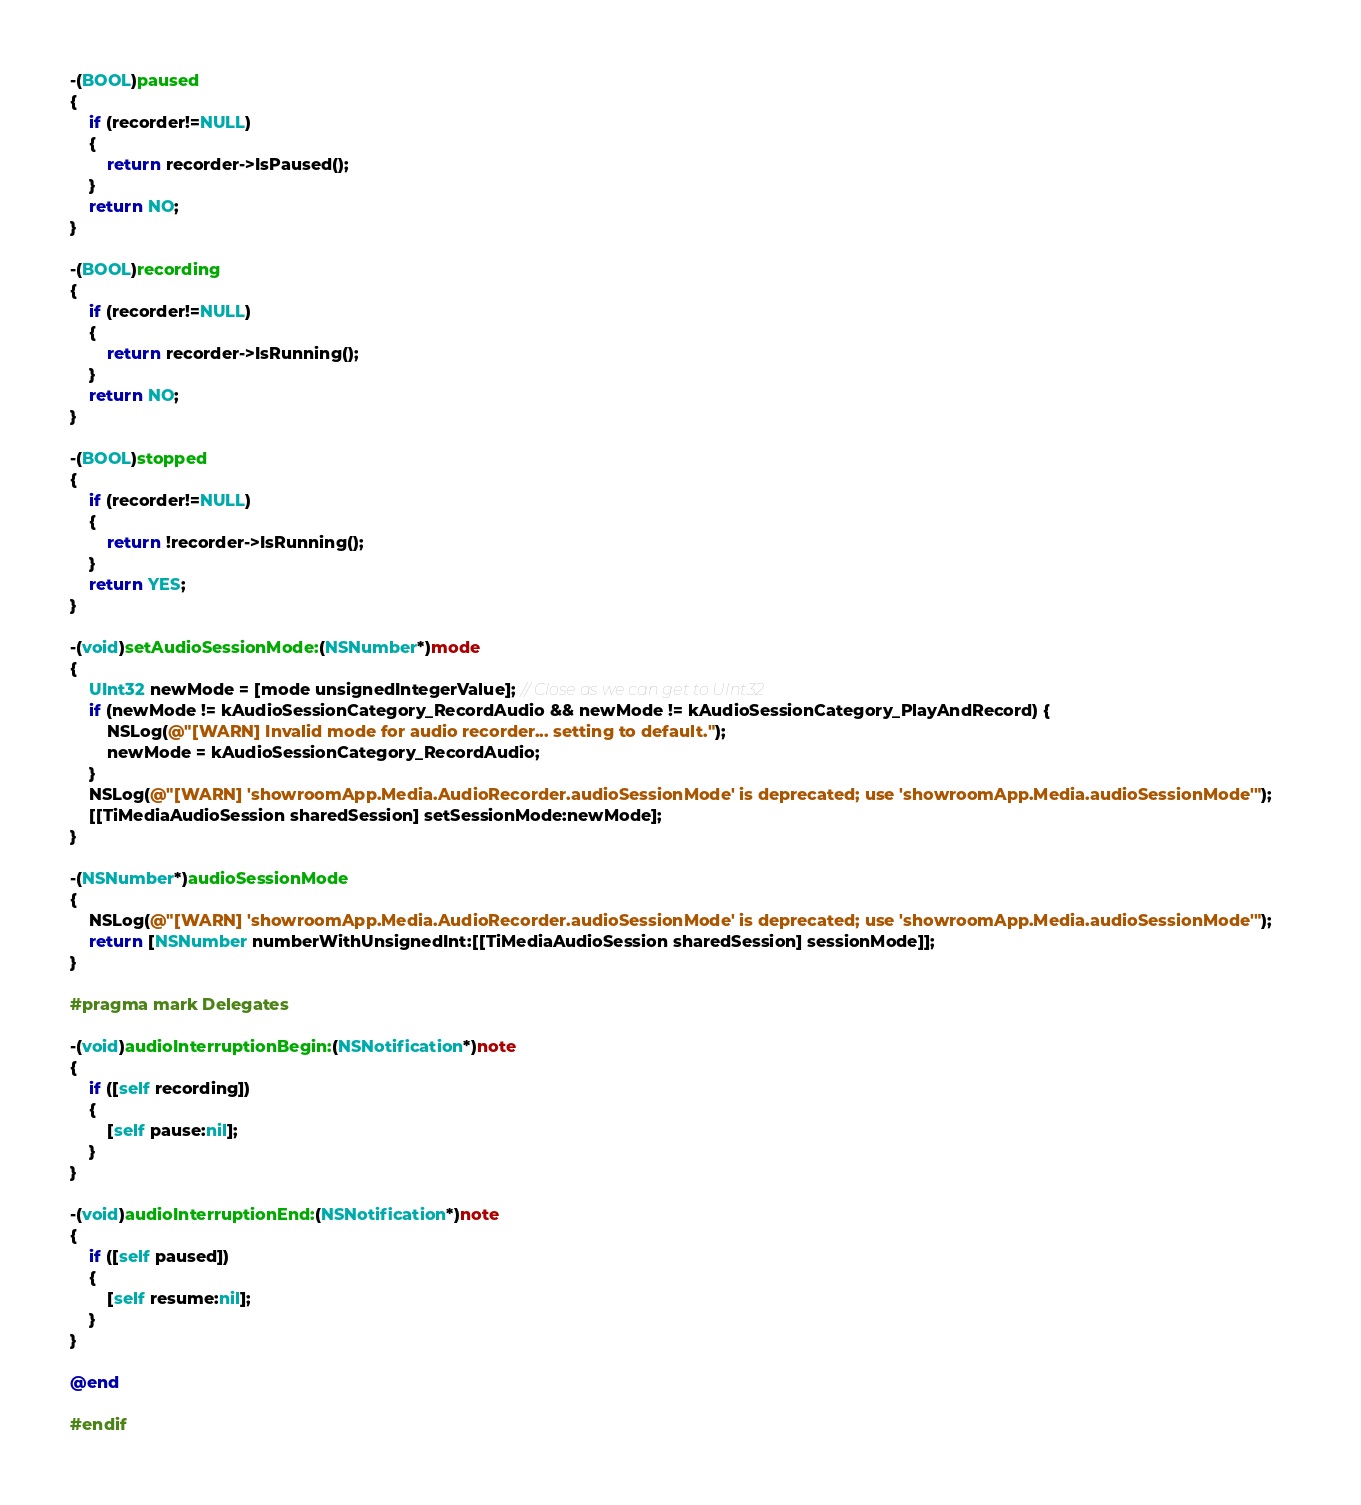<code> <loc_0><loc_0><loc_500><loc_500><_ObjectiveC_>
-(BOOL)paused
{
	if (recorder!=NULL)
	{
		return recorder->IsPaused();
	}
	return NO;
}

-(BOOL)recording
{
	if (recorder!=NULL)
	{
		return recorder->IsRunning();
	}
	return NO;
}

-(BOOL)stopped
{
	if (recorder!=NULL)
	{
		return !recorder->IsRunning();
	}
	return YES;
}

-(void)setAudioSessionMode:(NSNumber*)mode
{
    UInt32 newMode = [mode unsignedIntegerValue]; // Close as we can get to UInt32
    if (newMode != kAudioSessionCategory_RecordAudio && newMode != kAudioSessionCategory_PlayAndRecord) {
        NSLog(@"[WARN] Invalid mode for audio recorder... setting to default.");
        newMode = kAudioSessionCategory_RecordAudio;
    }
	NSLog(@"[WARN] 'showroomApp.Media.AudioRecorder.audioSessionMode' is deprecated; use 'showroomApp.Media.audioSessionMode'");
	[[TiMediaAudioSession sharedSession] setSessionMode:newMode];
}

-(NSNumber*)audioSessionMode
{
	NSLog(@"[WARN] 'showroomApp.Media.AudioRecorder.audioSessionMode' is deprecated; use 'showroomApp.Media.audioSessionMode'");	
    return [NSNumber numberWithUnsignedInt:[[TiMediaAudioSession sharedSession] sessionMode]];
}

#pragma mark Delegates 

-(void)audioInterruptionBegin:(NSNotification*)note
{
	if ([self recording]) 
	{
		[self pause:nil];
	}
}

-(void)audioInterruptionEnd:(NSNotification*)note
{
	if ([self paused])
	{
		[self resume:nil];
	}
}

@end

#endif</code> 